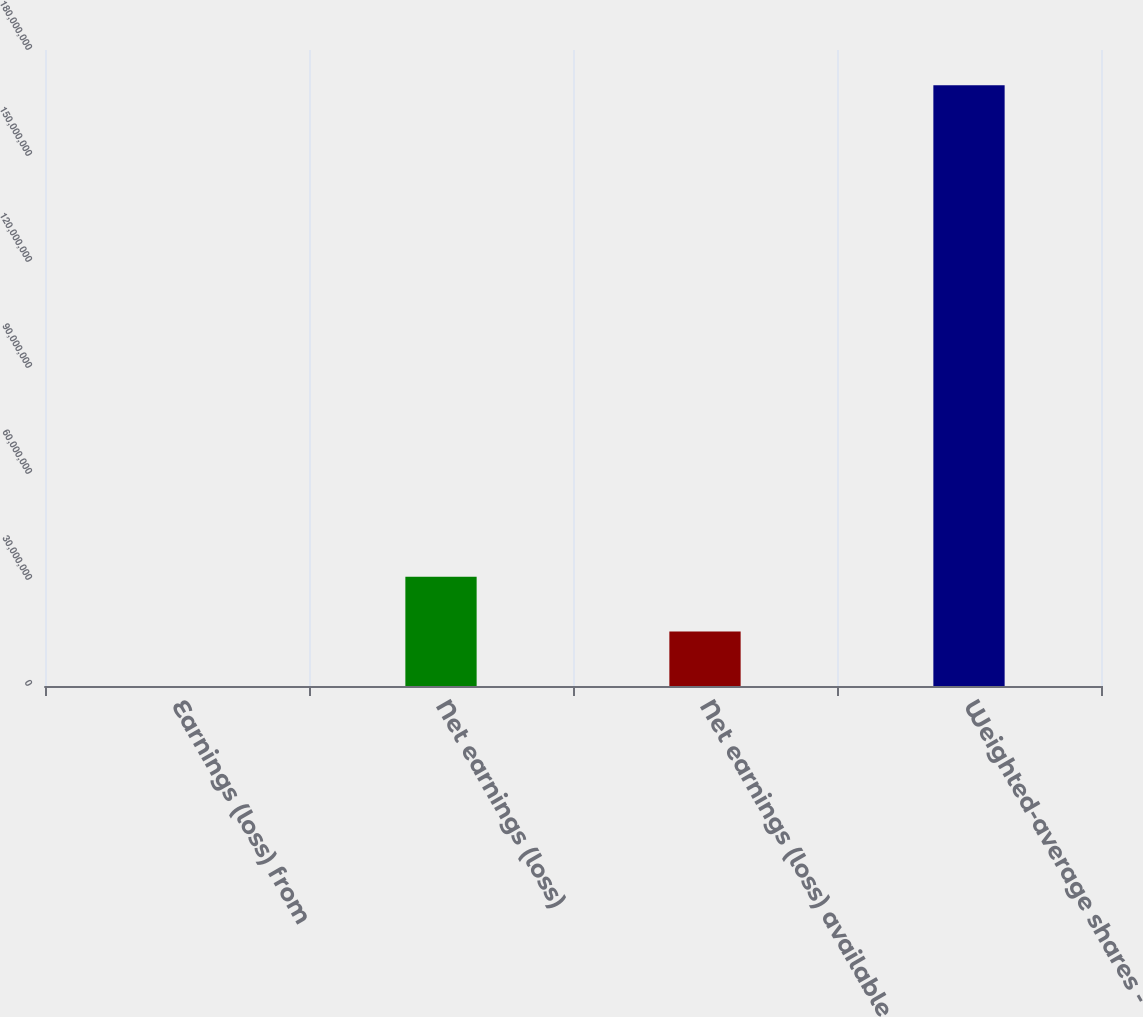<chart> <loc_0><loc_0><loc_500><loc_500><bar_chart><fcel>Earnings (loss) from<fcel>Net earnings (loss)<fcel>Net earnings (loss) available<fcel>Weighted-average shares -<nl><fcel>49<fcel>3.09129e+07<fcel>1.54565e+07<fcel>1.70021e+08<nl></chart> 